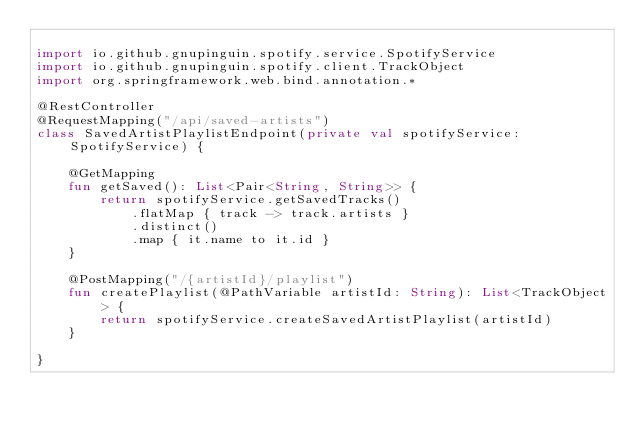Convert code to text. <code><loc_0><loc_0><loc_500><loc_500><_Kotlin_>
import io.github.gnupinguin.spotify.service.SpotifyService
import io.github.gnupinguin.spotify.client.TrackObject
import org.springframework.web.bind.annotation.*

@RestController
@RequestMapping("/api/saved-artists")
class SavedArtistPlaylistEndpoint(private val spotifyService: SpotifyService) {

    @GetMapping
    fun getSaved(): List<Pair<String, String>> {
        return spotifyService.getSavedTracks()
            .flatMap { track -> track.artists }
            .distinct()
            .map { it.name to it.id }
    }

    @PostMapping("/{artistId}/playlist")
    fun createPlaylist(@PathVariable artistId: String): List<TrackObject> {
        return spotifyService.createSavedArtistPlaylist(artistId)
    }

}</code> 